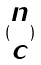Convert formula to latex. <formula><loc_0><loc_0><loc_500><loc_500>( \begin{matrix} n \\ c \end{matrix} )</formula> 